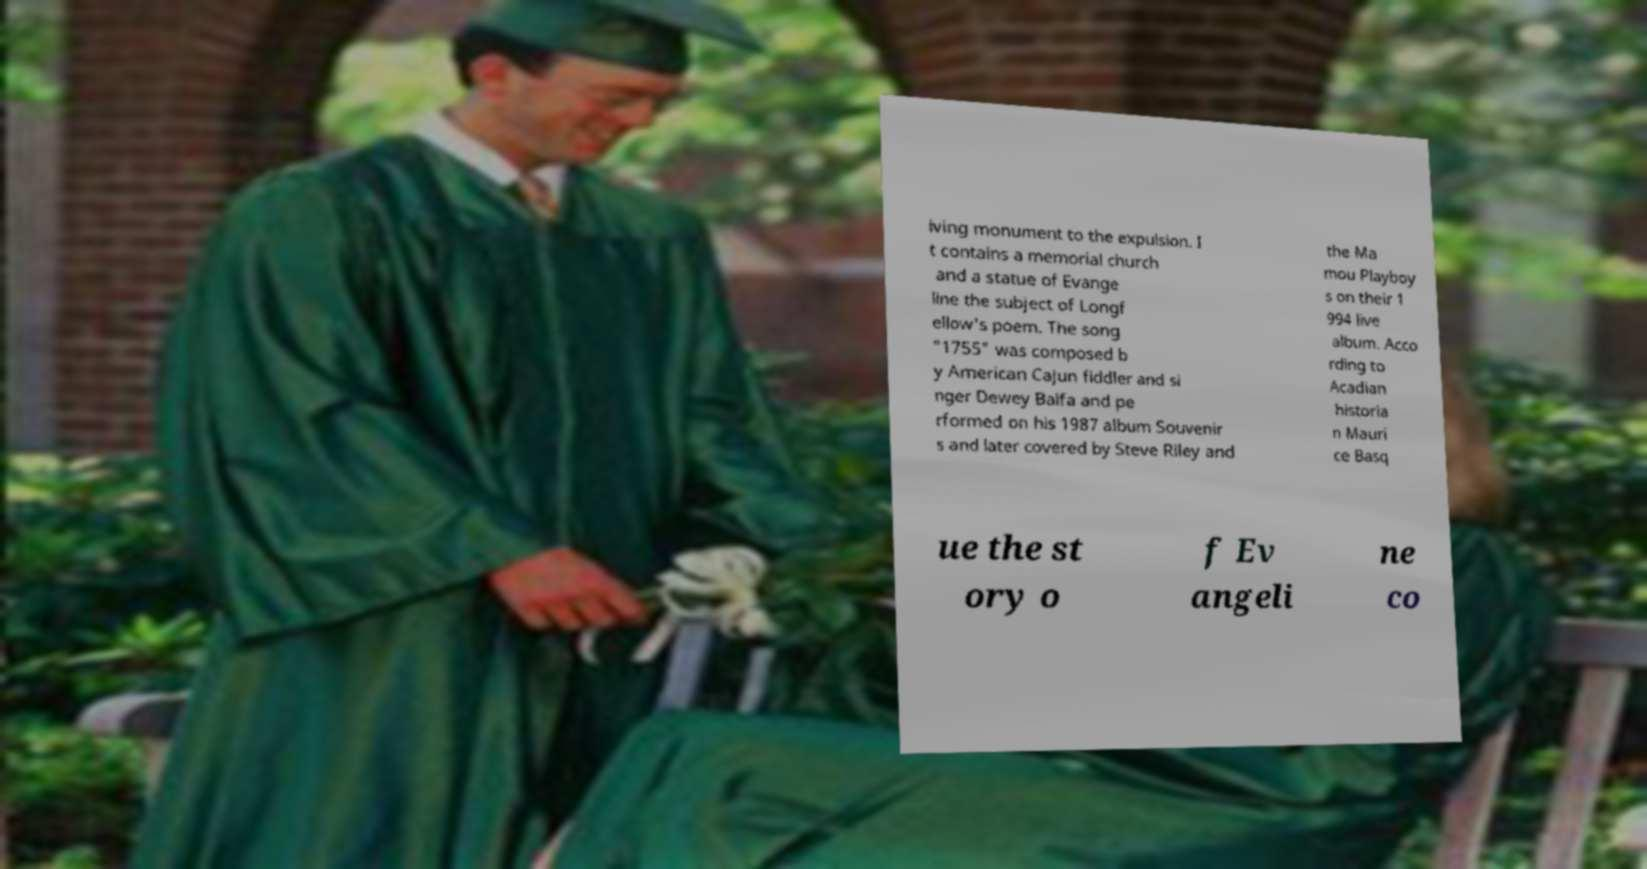There's text embedded in this image that I need extracted. Can you transcribe it verbatim? iving monument to the expulsion. I t contains a memorial church and a statue of Evange line the subject of Longf ellow's poem. The song "1755" was composed b y American Cajun fiddler and si nger Dewey Balfa and pe rformed on his 1987 album Souvenir s and later covered by Steve Riley and the Ma mou Playboy s on their 1 994 live album. Acco rding to Acadian historia n Mauri ce Basq ue the st ory o f Ev angeli ne co 